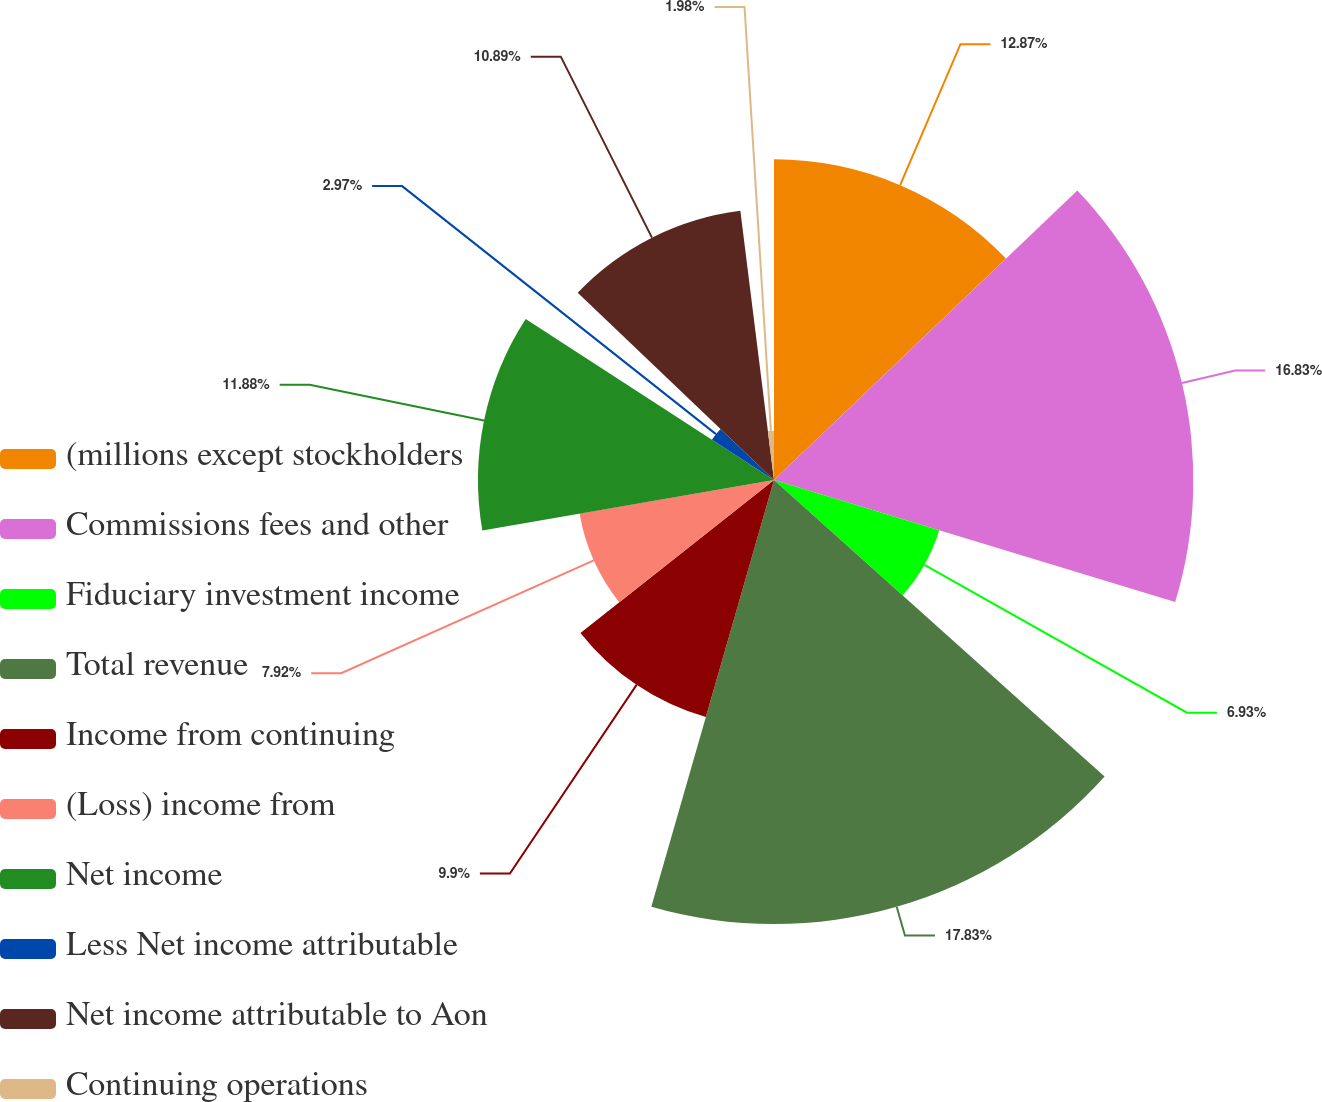Convert chart to OTSL. <chart><loc_0><loc_0><loc_500><loc_500><pie_chart><fcel>(millions except stockholders<fcel>Commissions fees and other<fcel>Fiduciary investment income<fcel>Total revenue<fcel>Income from continuing<fcel>(Loss) income from<fcel>Net income<fcel>Less Net income attributable<fcel>Net income attributable to Aon<fcel>Continuing operations<nl><fcel>12.87%<fcel>16.83%<fcel>6.93%<fcel>17.82%<fcel>9.9%<fcel>7.92%<fcel>11.88%<fcel>2.97%<fcel>10.89%<fcel>1.98%<nl></chart> 